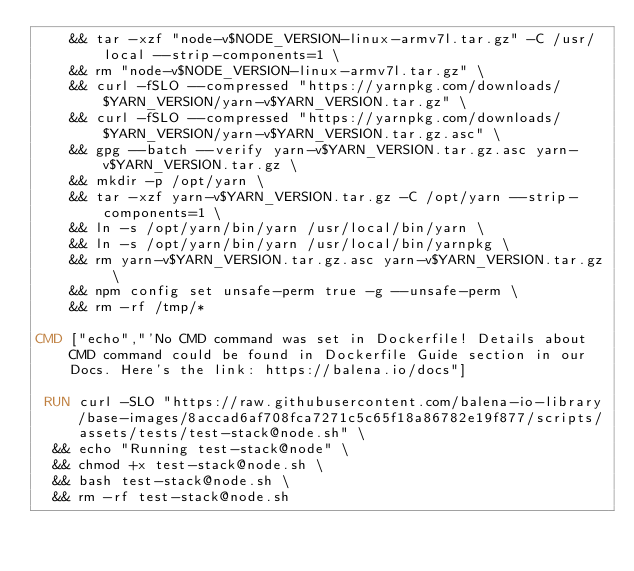<code> <loc_0><loc_0><loc_500><loc_500><_Dockerfile_>	&& tar -xzf "node-v$NODE_VERSION-linux-armv7l.tar.gz" -C /usr/local --strip-components=1 \
	&& rm "node-v$NODE_VERSION-linux-armv7l.tar.gz" \
	&& curl -fSLO --compressed "https://yarnpkg.com/downloads/$YARN_VERSION/yarn-v$YARN_VERSION.tar.gz" \
	&& curl -fSLO --compressed "https://yarnpkg.com/downloads/$YARN_VERSION/yarn-v$YARN_VERSION.tar.gz.asc" \
	&& gpg --batch --verify yarn-v$YARN_VERSION.tar.gz.asc yarn-v$YARN_VERSION.tar.gz \
	&& mkdir -p /opt/yarn \
	&& tar -xzf yarn-v$YARN_VERSION.tar.gz -C /opt/yarn --strip-components=1 \
	&& ln -s /opt/yarn/bin/yarn /usr/local/bin/yarn \
	&& ln -s /opt/yarn/bin/yarn /usr/local/bin/yarnpkg \
	&& rm yarn-v$YARN_VERSION.tar.gz.asc yarn-v$YARN_VERSION.tar.gz \
	&& npm config set unsafe-perm true -g --unsafe-perm \
	&& rm -rf /tmp/*

CMD ["echo","'No CMD command was set in Dockerfile! Details about CMD command could be found in Dockerfile Guide section in our Docs. Here's the link: https://balena.io/docs"]

 RUN curl -SLO "https://raw.githubusercontent.com/balena-io-library/base-images/8accad6af708fca7271c5c65f18a86782e19f877/scripts/assets/tests/test-stack@node.sh" \
  && echo "Running test-stack@node" \
  && chmod +x test-stack@node.sh \
  && bash test-stack@node.sh \
  && rm -rf test-stack@node.sh 
</code> 